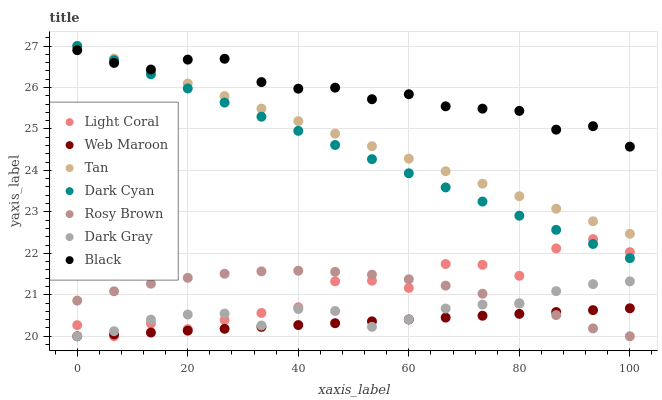Does Web Maroon have the minimum area under the curve?
Answer yes or no. Yes. Does Black have the maximum area under the curve?
Answer yes or no. Yes. Does Rosy Brown have the minimum area under the curve?
Answer yes or no. No. Does Rosy Brown have the maximum area under the curve?
Answer yes or no. No. Is Tan the smoothest?
Answer yes or no. Yes. Is Light Coral the roughest?
Answer yes or no. Yes. Is Rosy Brown the smoothest?
Answer yes or no. No. Is Rosy Brown the roughest?
Answer yes or no. No. Does Dark Gray have the lowest value?
Answer yes or no. Yes. Does Black have the lowest value?
Answer yes or no. No. Does Tan have the highest value?
Answer yes or no. Yes. Does Rosy Brown have the highest value?
Answer yes or no. No. Is Dark Gray less than Black?
Answer yes or no. Yes. Is Tan greater than Light Coral?
Answer yes or no. Yes. Does Rosy Brown intersect Light Coral?
Answer yes or no. Yes. Is Rosy Brown less than Light Coral?
Answer yes or no. No. Is Rosy Brown greater than Light Coral?
Answer yes or no. No. Does Dark Gray intersect Black?
Answer yes or no. No. 